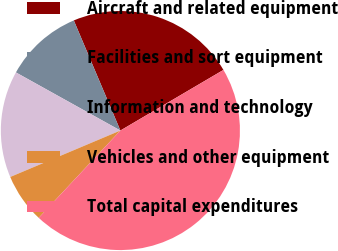<chart> <loc_0><loc_0><loc_500><loc_500><pie_chart><fcel>Aircraft and related equipment<fcel>Facilities and sort equipment<fcel>Information and technology<fcel>Vehicles and other equipment<fcel>Total capital expenditures<nl><fcel>22.91%<fcel>10.55%<fcel>14.43%<fcel>6.68%<fcel>45.43%<nl></chart> 